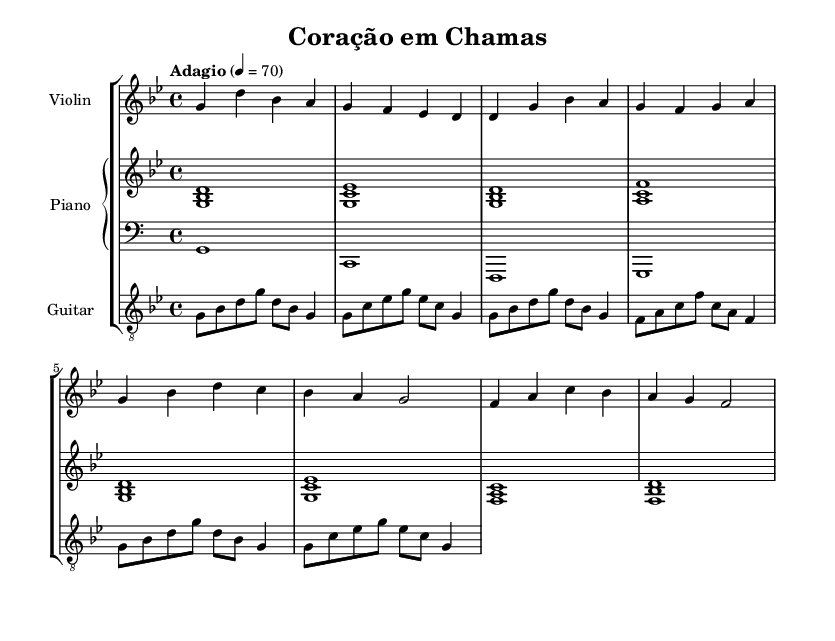What is the key signature of this music? The key signature is indicated at the beginning of the sheet music, showing two flats (B♭ and E♭), which corresponds to the key of G minor.
Answer: G minor What is the time signature of this piece? The time signature is printed next to the key signature, showing a "4/4" which signifies that there are 4 beats in each measure and a quarter note gets one beat.
Answer: 4/4 What is the tempo marking for this music? The tempo marking is listed at the beginning of the score as "Adagio" which indicates a slow pace, and it specifies a metronomic value of 70 beats per minute.
Answer: Adagio, 70 How many measures are in the chorus section? The chorus section is identifiable through its musical notation, and I can count that it contains 4 measures based on the barlines separating the music.
Answer: 4 What instruments are included in the score? The instruments are listed at the beginning of each staff, showing a violin, piano, and guitar, which makes it clear which instruments are involved in the performance of this piece.
Answer: Violin, Piano, Guitar What is the last note of the introduction? The last note of the introduction can be found in the first section of the violin staff, which shows that the sequence ends on a D note.
Answer: D Which instrument's part begins with a chord in the introduction? In the introduction section, the piano part starts with a chord consisting of G, B♭, and D, indicating it begins with harmonic accompaniment.
Answer: Piano 